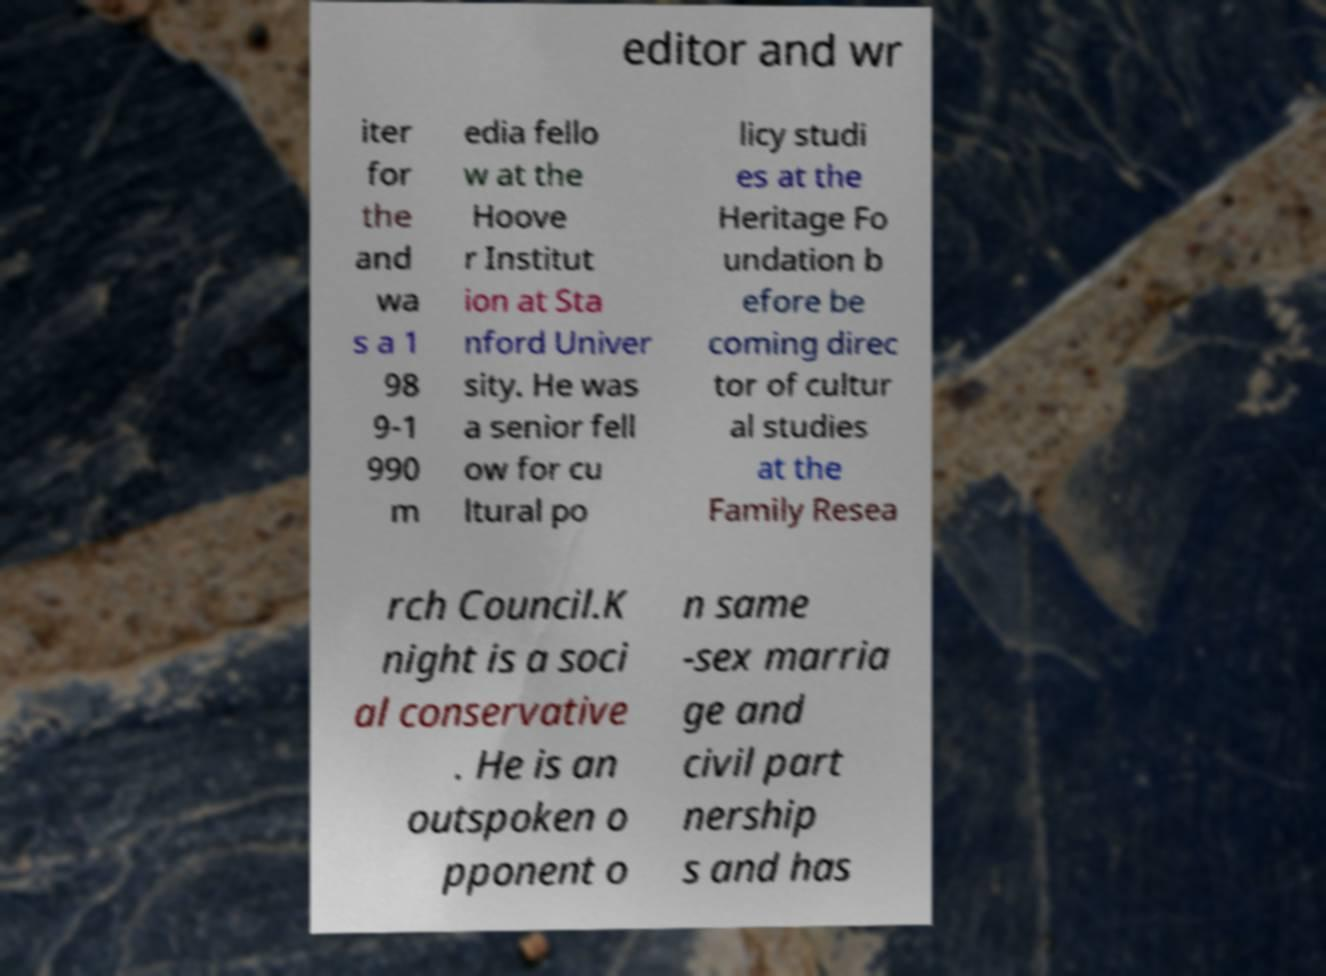I need the written content from this picture converted into text. Can you do that? editor and wr iter for the and wa s a 1 98 9-1 990 m edia fello w at the Hoove r Institut ion at Sta nford Univer sity. He was a senior fell ow for cu ltural po licy studi es at the Heritage Fo undation b efore be coming direc tor of cultur al studies at the Family Resea rch Council.K night is a soci al conservative . He is an outspoken o pponent o n same -sex marria ge and civil part nership s and has 